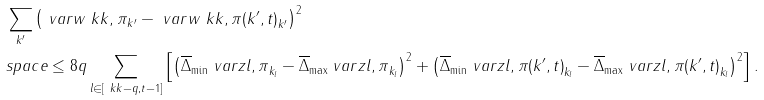<formula> <loc_0><loc_0><loc_500><loc_500>& \sum _ { k ^ { \prime } } \left ( \ v a r { w } { \ k k , \pi } _ { k ^ { \prime } } - \ v a r { w } { \ k k , \pi ( k ^ { \prime } , t ) } _ { k ^ { \prime } } \right ) ^ { 2 } \\ & s p a c e \leq 8 q \sum _ { l \in [ \ k k - q , t - 1 ] } \left [ \left ( \overline { \Delta } _ { \min } \ v a r { z } { l , \pi } _ { k _ { l } } - \overline { \Delta } _ { \max } \ v a r { z } { l , \pi } _ { k _ { l } } \right ) ^ { 2 } + \left ( \overline { \Delta } _ { \min } \ v a r { z } { l , \pi ( k ^ { \prime } , t ) } _ { k _ { l } } - \overline { \Delta } _ { \max } \ v a r { z } { l , \pi ( k ^ { \prime } , t ) } _ { k _ { l } } \right ) ^ { 2 } \right ] .</formula> 